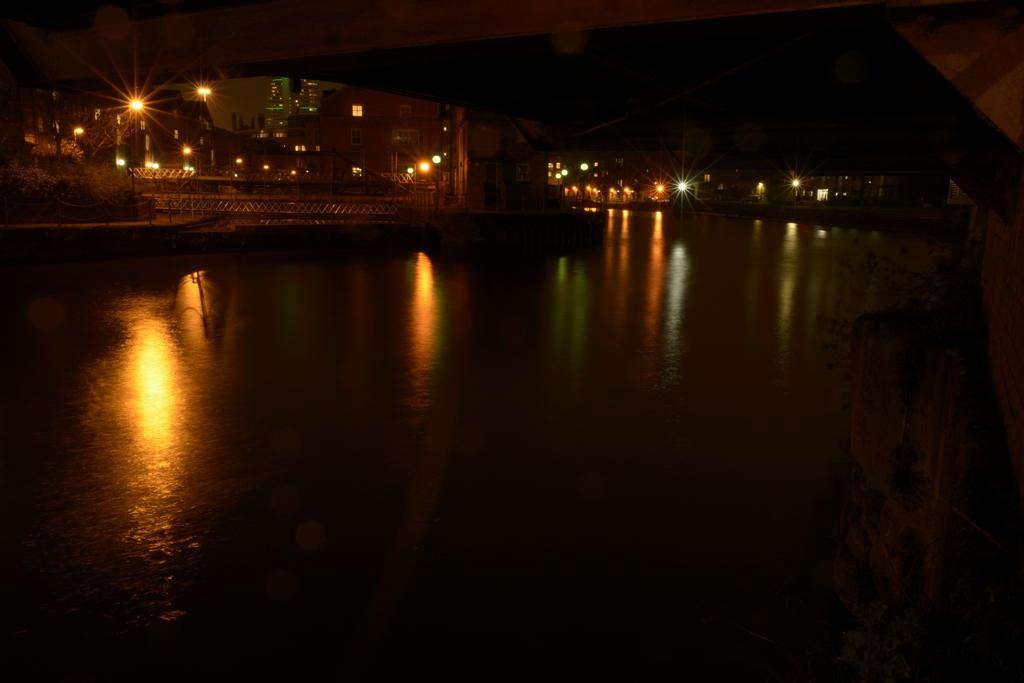What is the overall lighting condition in the image? The image is dark. What can be seen at the bottom of the image? There is water visible at the bottom of the image. What is visible in the background of the image? Buildings, light poles, windows, and other objects are present in the background of the image. Where are the plants located in the image? The plants are on the right side of the image. What is the wall located on the right side of the image? There is a wall on the right side of the image. Can you hear the fairies singing in the image? There are no fairies present in the image, and therefore no singing can be heard. What type of car is parked near the wall in the image? There is no car present in the image; it only features water, plants, a wall, and background objects. 